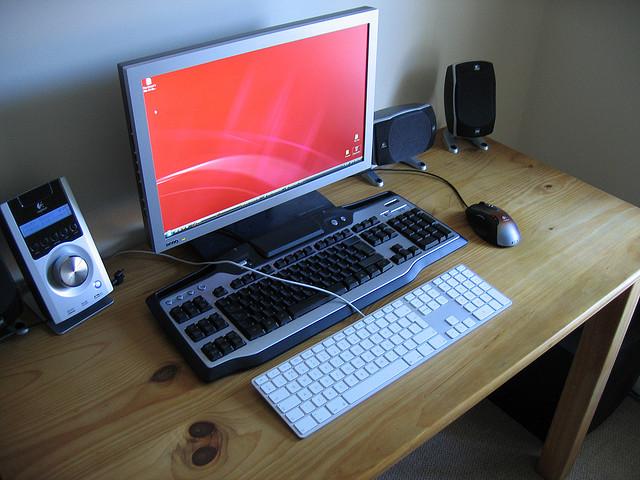What material is this table made of?
Give a very brief answer. Wood. Does the mouse have a cord?
Concise answer only. Yes. What color is the comp screen?
Quick response, please. Red. Is this a portable tablet?
Write a very short answer. No. 